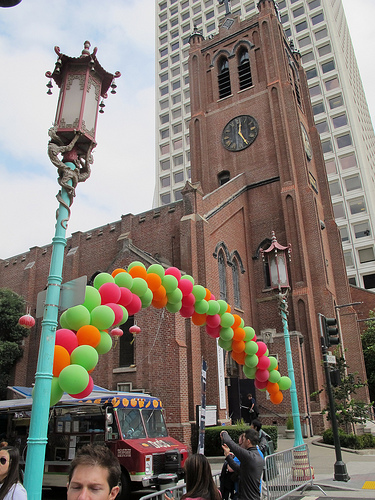<image>
Is there a man next to the man two? No. The man is not positioned next to the man two. They are located in different areas of the scene. 